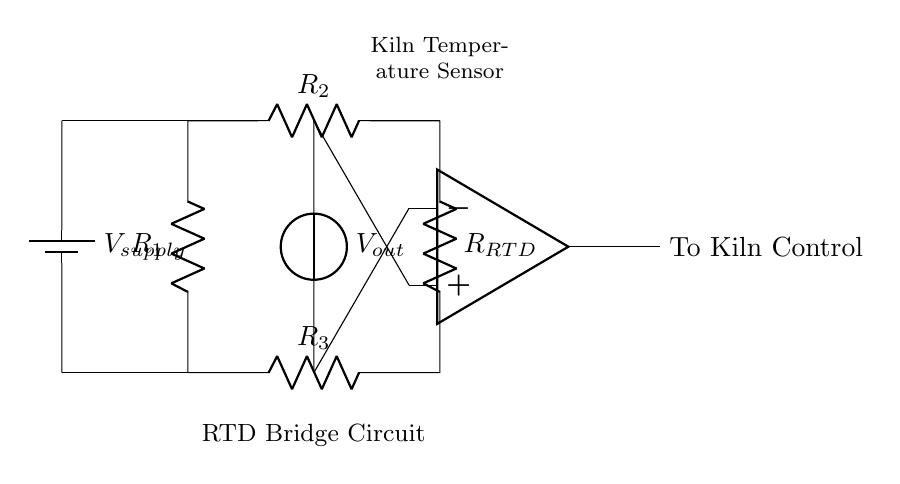What type of circuit is this? This is a bridge circuit, specifically a resistance temperature detector (RTD) bridge circuit. It is used to measure temperature by balancing the resistance of the RTD with other resistances in the bridge configuration.
Answer: Bridge circuit What is the purpose of the op-amp in this circuit? The operational amplifier (op-amp) amplifies the voltage difference across the bridge circuit, providing a signal to control the kiln. This helps to precisely control the temperature based on the readings from the RTD sensor.
Answer: Amplification What component measures temperature in this circuit? The component that measures temperature is the resistance temperature detector (RTD), denoted as R_RTD. It changes its resistance based on the temperature, which in turn affects the output of the bridge circuit.
Answer: R_RTD How many resistors are in this circuit? There are four resistors in total, labeled R_1, R_2, R_3, and R_4, in addition to the R_RTD which acts like a resistor in the circuit.
Answer: Four What is the configuration of the resistors in this bridge circuit? The resistors R_1 and R_2 are in series with the power supply, while R_3 and R_4 form the lower leg of the bridge with the RTD. This allows for a balanced configuration that can detect changes in resistance caused by temperature changes.
Answer: Series-parallel What is the source of power in this circuit? The source of power is a battery, labeled V_supply, which provides the necessary voltage to the bridge circuit for it to operate effectively and measure temperature.
Answer: Battery 